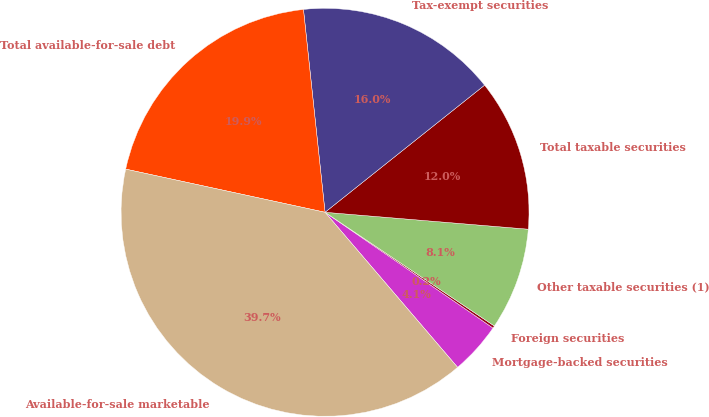<chart> <loc_0><loc_0><loc_500><loc_500><pie_chart><fcel>Mortgage-backed securities<fcel>Foreign securities<fcel>Other taxable securities (1)<fcel>Total taxable securities<fcel>Tax-exempt securities<fcel>Total available-for-sale debt<fcel>Available-for-sale marketable<nl><fcel>4.14%<fcel>0.19%<fcel>8.09%<fcel>12.03%<fcel>15.98%<fcel>19.92%<fcel>39.65%<nl></chart> 